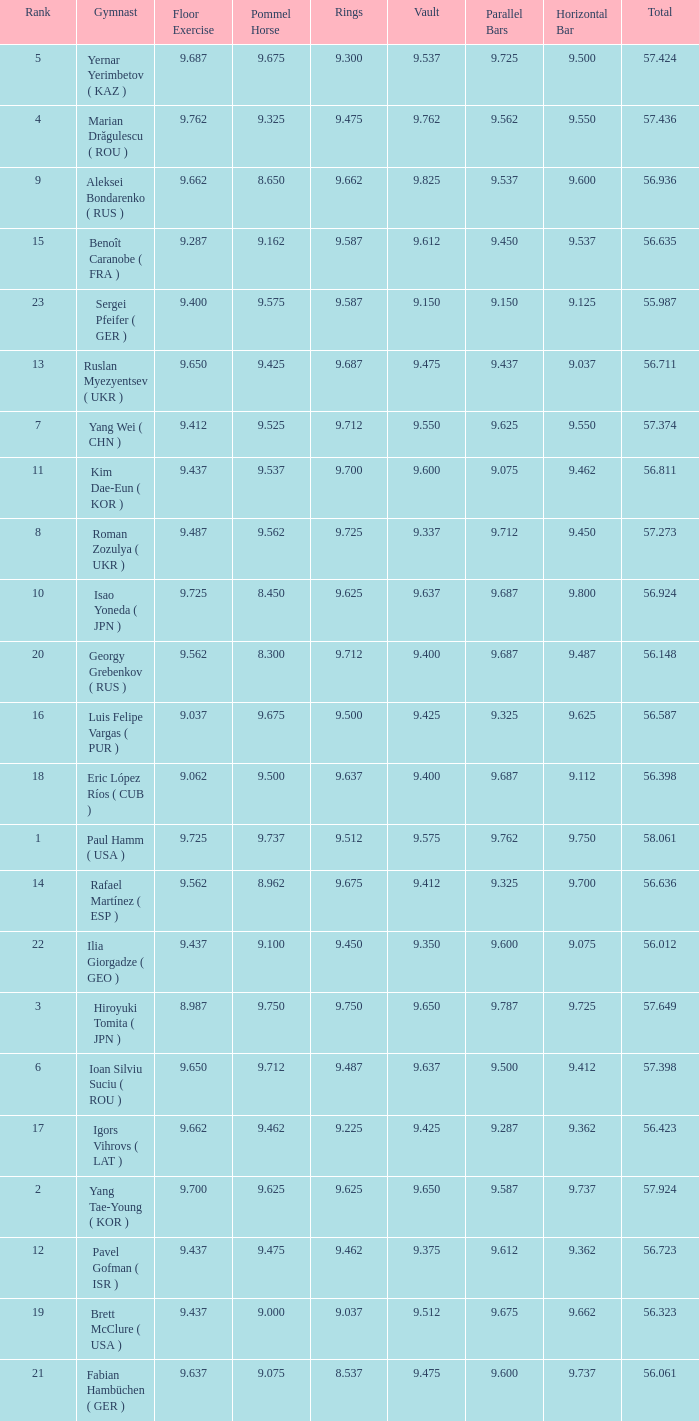What is the vault score for the total of 56.635? 9.612. 